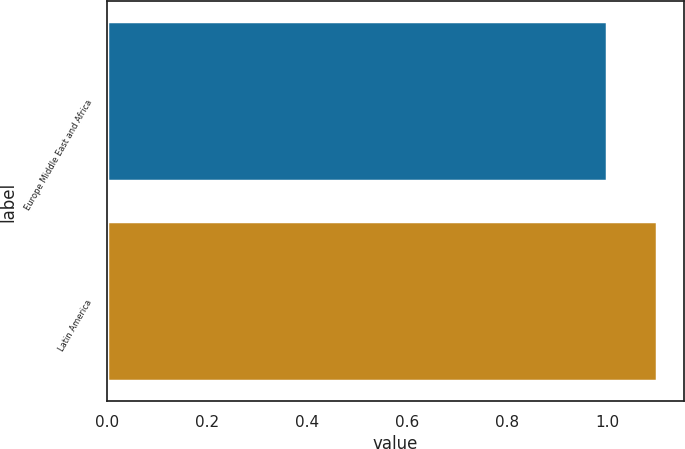<chart> <loc_0><loc_0><loc_500><loc_500><bar_chart><fcel>Europe Middle East and Africa<fcel>Latin America<nl><fcel>1<fcel>1.1<nl></chart> 